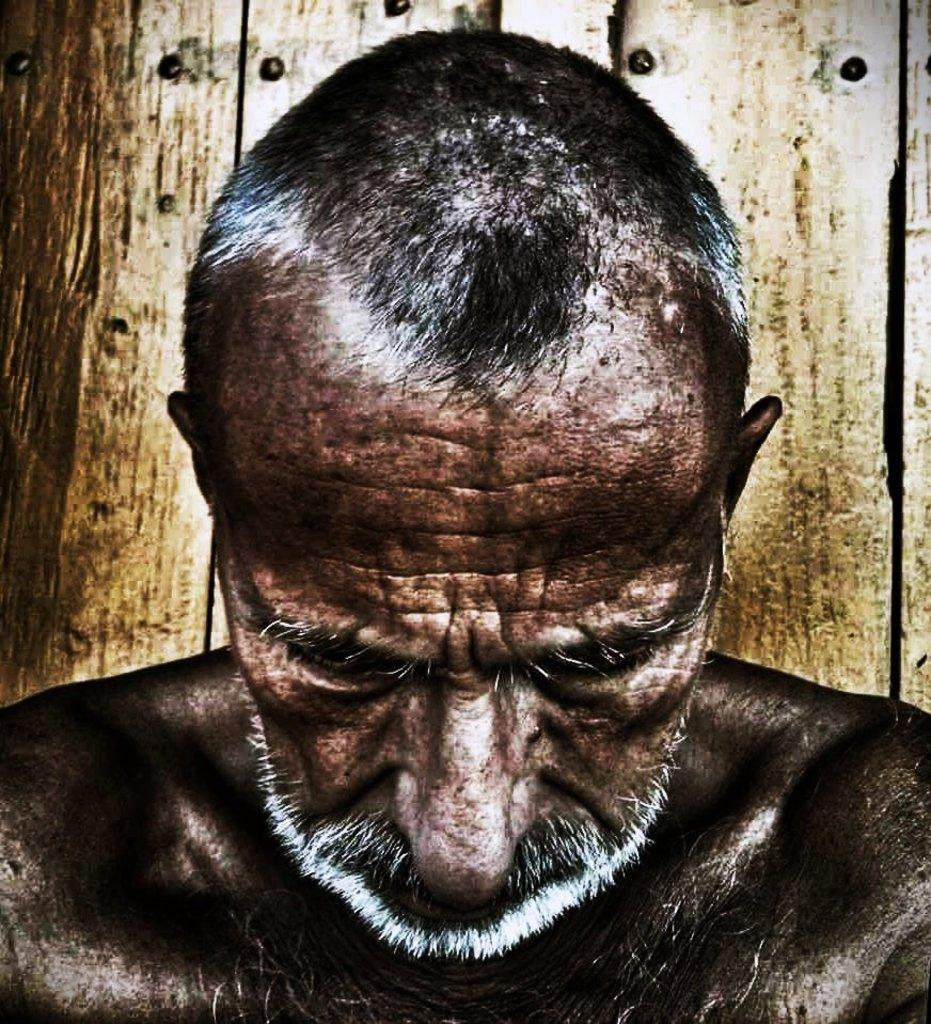What is the main subject of the image? There is a person in the image. What can be seen behind the person? The person is in front of a wooden wall. How much money is the person holding in the image? There is no indication of money in the image; the person is simply standing in front of a wooden wall. 